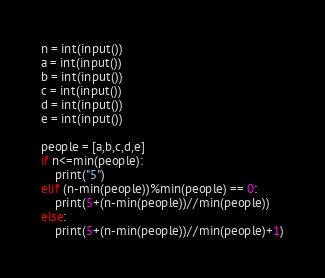Convert code to text. <code><loc_0><loc_0><loc_500><loc_500><_Python_>n = int(input())
a = int(input())
b = int(input())
c = int(input())
d = int(input())
e = int(input())

people = [a,b,c,d,e]
if n<=min(people):
    print("5")
elif (n-min(people))%min(people) == 0:
    print(5+(n-min(people))//min(people))
else:
    print(5+(n-min(people))//min(people)+1)</code> 